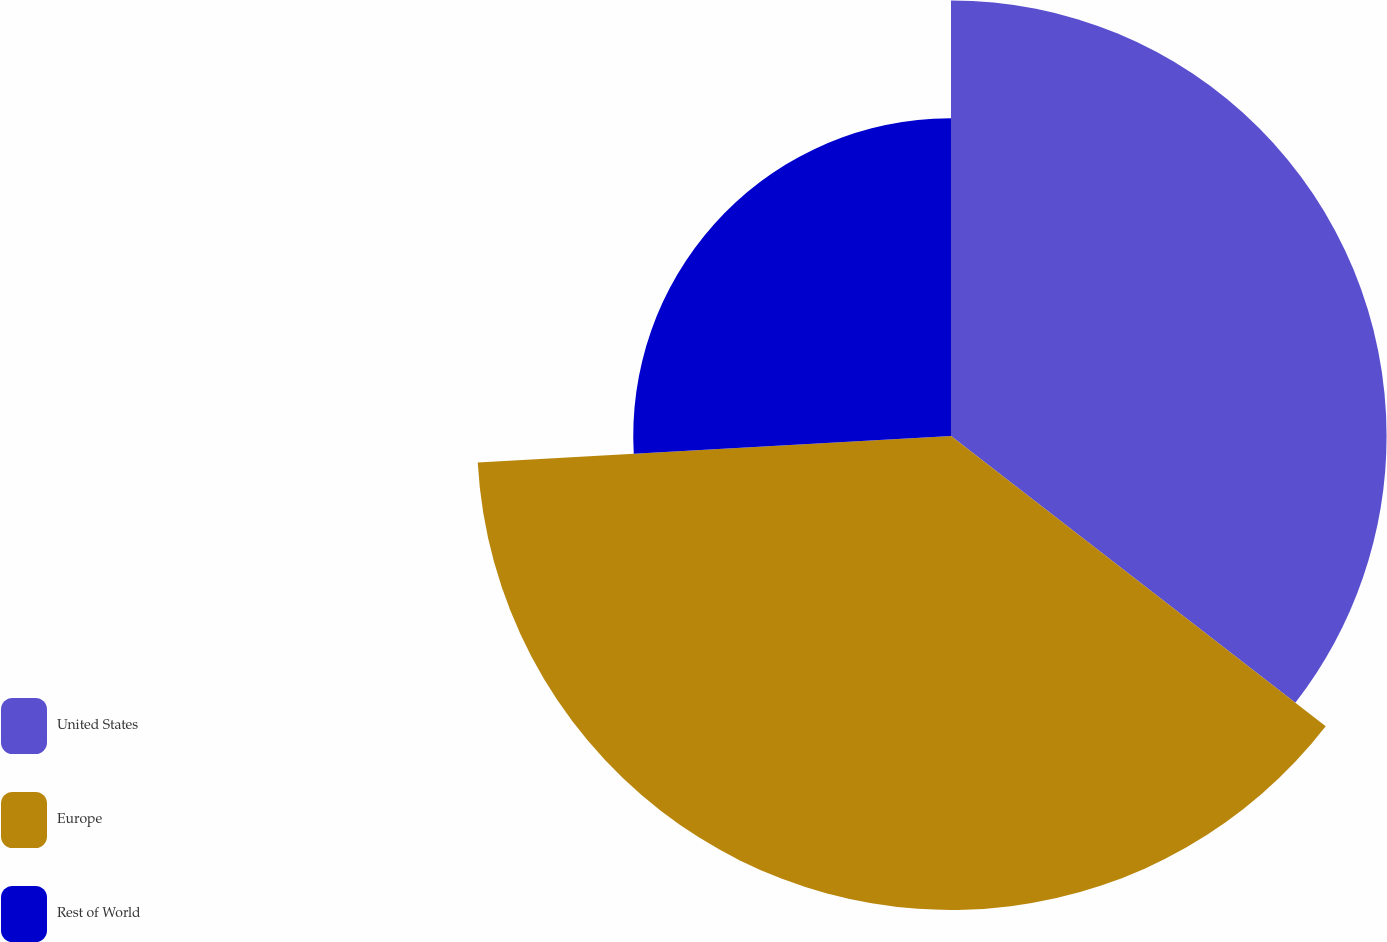Convert chart to OTSL. <chart><loc_0><loc_0><loc_500><loc_500><pie_chart><fcel>United States<fcel>Europe<fcel>Rest of World<nl><fcel>35.49%<fcel>38.62%<fcel>25.89%<nl></chart> 